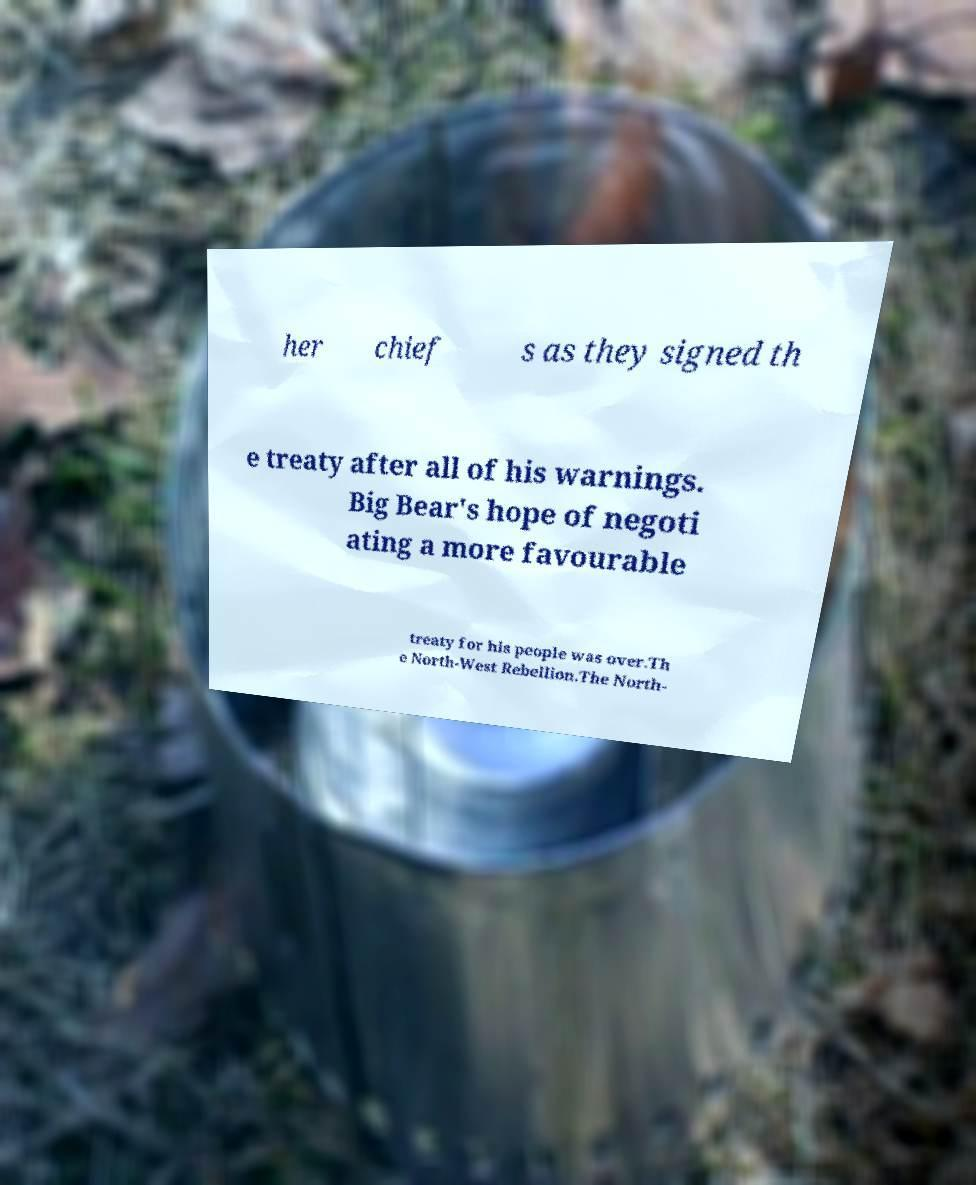What messages or text are displayed in this image? I need them in a readable, typed format. her chief s as they signed th e treaty after all of his warnings. Big Bear's hope of negoti ating a more favourable treaty for his people was over.Th e North-West Rebellion.The North- 